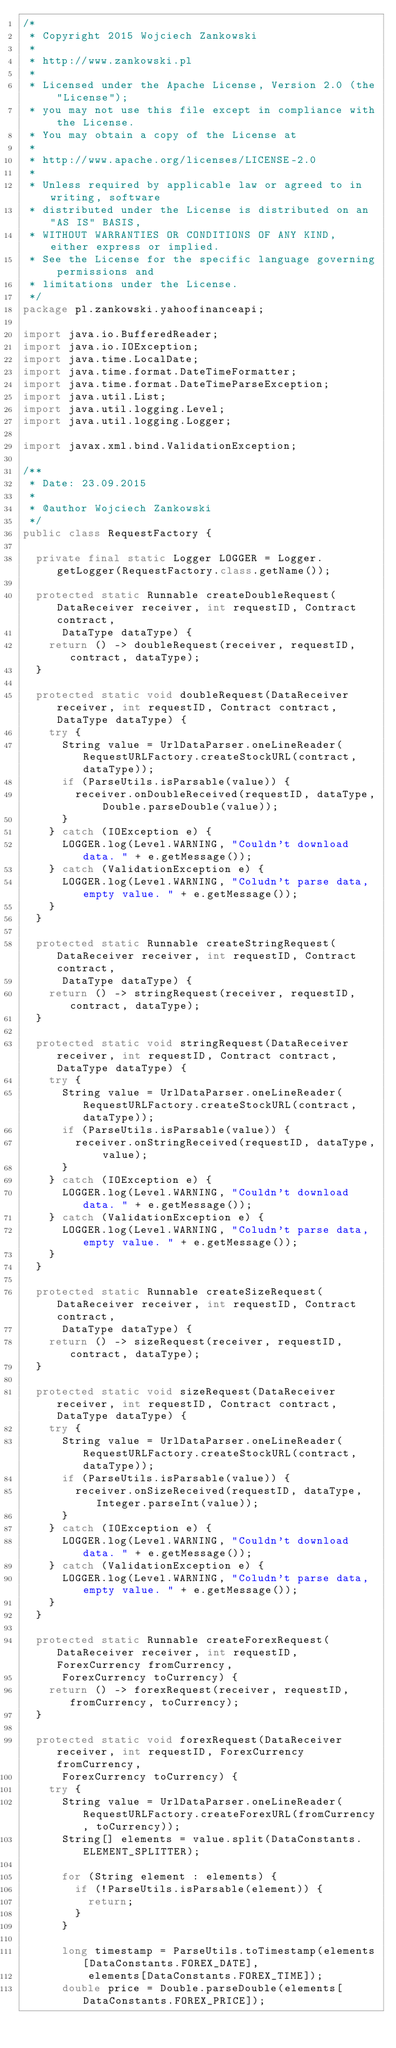<code> <loc_0><loc_0><loc_500><loc_500><_Java_>/*
 * Copyright 2015 Wojciech Zankowski
 *
 * http://www.zankowski.pl
 *
 * Licensed under the Apache License, Version 2.0 (the "License");
 * you may not use this file except in compliance with the License.
 * You may obtain a copy of the License at
 *
 * http://www.apache.org/licenses/LICENSE-2.0
 *
 * Unless required by applicable law or agreed to in writing, software
 * distributed under the License is distributed on an "AS IS" BASIS,
 * WITHOUT WARRANTIES OR CONDITIONS OF ANY KIND, either express or implied.
 * See the License for the specific language governing permissions and
 * limitations under the License.
 */
package pl.zankowski.yahoofinanceapi;

import java.io.BufferedReader;
import java.io.IOException;
import java.time.LocalDate;
import java.time.format.DateTimeFormatter;
import java.time.format.DateTimeParseException;
import java.util.List;
import java.util.logging.Level;
import java.util.logging.Logger;

import javax.xml.bind.ValidationException;

/**
 * Date: 23.09.2015
 *
 * @author Wojciech Zankowski
 */
public class RequestFactory {

	private final static Logger LOGGER = Logger.getLogger(RequestFactory.class.getName());

	protected static Runnable createDoubleRequest(DataReceiver receiver, int requestID, Contract contract,
			DataType dataType) {
		return () -> doubleRequest(receiver, requestID, contract, dataType);
	}

	protected static void doubleRequest(DataReceiver receiver, int requestID, Contract contract, DataType dataType) {
		try {
			String value = UrlDataParser.oneLineReader(RequestURLFactory.createStockURL(contract, dataType));
			if (ParseUtils.isParsable(value)) {
				receiver.onDoubleReceived(requestID, dataType, Double.parseDouble(value));
			}
		} catch (IOException e) {
			LOGGER.log(Level.WARNING, "Couldn't download data. " + e.getMessage());
		} catch (ValidationException e) {
			LOGGER.log(Level.WARNING, "Coludn't parse data, empty value. " + e.getMessage());
		}
	}

	protected static Runnable createStringRequest(DataReceiver receiver, int requestID, Contract contract,
			DataType dataType) {
		return () -> stringRequest(receiver, requestID, contract, dataType);
	}

	protected static void stringRequest(DataReceiver receiver, int requestID, Contract contract, DataType dataType) {
		try {
			String value = UrlDataParser.oneLineReader(RequestURLFactory.createStockURL(contract, dataType));
			if (ParseUtils.isParsable(value)) {
				receiver.onStringReceived(requestID, dataType, value);
			}
		} catch (IOException e) {
			LOGGER.log(Level.WARNING, "Couldn't download data. " + e.getMessage());
		} catch (ValidationException e) {
			LOGGER.log(Level.WARNING, "Coludn't parse data, empty value. " + e.getMessage());
		}
	}

	protected static Runnable createSizeRequest(DataReceiver receiver, int requestID, Contract contract,
			DataType dataType) {
		return () -> sizeRequest(receiver, requestID, contract, dataType);
	}

	protected static void sizeRequest(DataReceiver receiver, int requestID, Contract contract, DataType dataType) {
		try {
			String value = UrlDataParser.oneLineReader(RequestURLFactory.createStockURL(contract, dataType));
			if (ParseUtils.isParsable(value)) {
				receiver.onSizeReceived(requestID, dataType, Integer.parseInt(value));
			}
		} catch (IOException e) {
			LOGGER.log(Level.WARNING, "Couldn't download data. " + e.getMessage());
		} catch (ValidationException e) {
			LOGGER.log(Level.WARNING, "Coludn't parse data, empty value. " + e.getMessage());
		}
	}

	protected static Runnable createForexRequest(DataReceiver receiver, int requestID, ForexCurrency fromCurrency,
			ForexCurrency toCurrency) {
		return () -> forexRequest(receiver, requestID, fromCurrency, toCurrency);
	}

	protected static void forexRequest(DataReceiver receiver, int requestID, ForexCurrency fromCurrency,
			ForexCurrency toCurrency) {
		try {
			String value = UrlDataParser.oneLineReader(RequestURLFactory.createForexURL(fromCurrency, toCurrency));
			String[] elements = value.split(DataConstants.ELEMENT_SPLITTER);

			for (String element : elements) {
				if (!ParseUtils.isParsable(element)) {
					return;
				}
			}

			long timestamp = ParseUtils.toTimestamp(elements[DataConstants.FOREX_DATE],
					elements[DataConstants.FOREX_TIME]);
			double price = Double.parseDouble(elements[DataConstants.FOREX_PRICE]);
</code> 